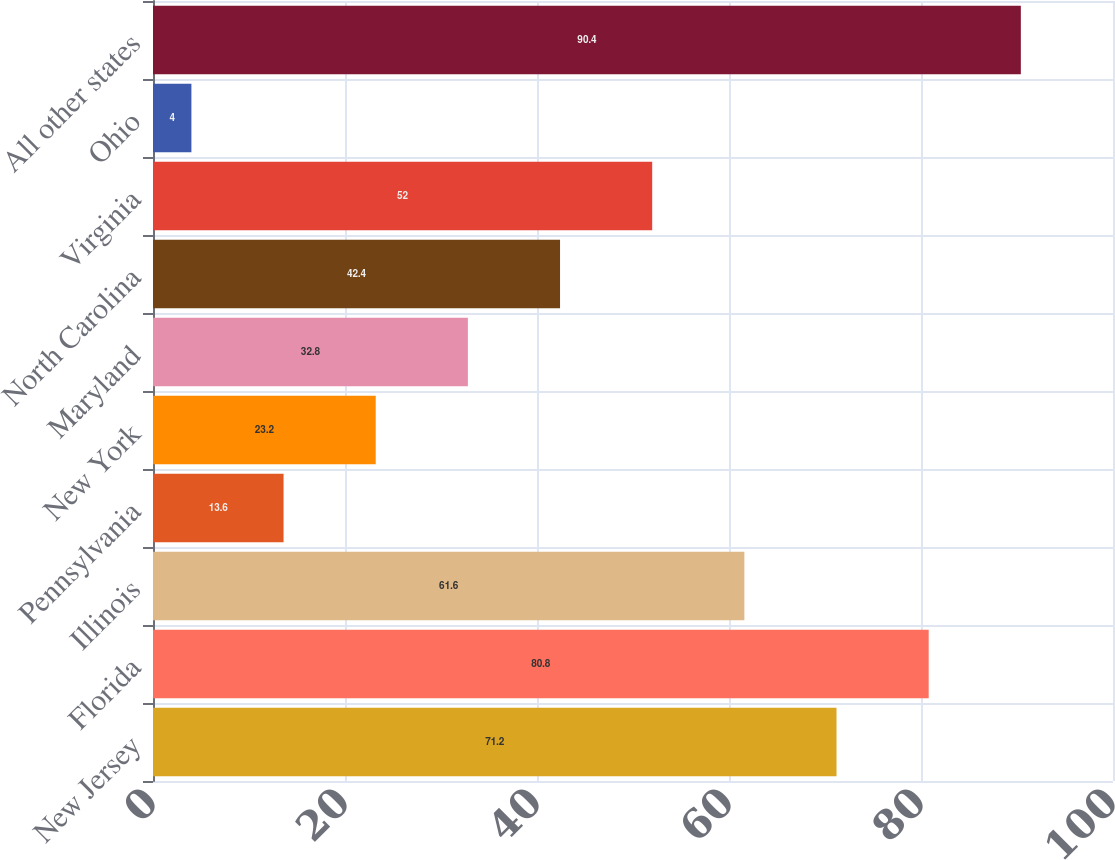Convert chart to OTSL. <chart><loc_0><loc_0><loc_500><loc_500><bar_chart><fcel>New Jersey<fcel>Florida<fcel>Illinois<fcel>Pennsylvania<fcel>New York<fcel>Maryland<fcel>North Carolina<fcel>Virginia<fcel>Ohio<fcel>All other states<nl><fcel>71.2<fcel>80.8<fcel>61.6<fcel>13.6<fcel>23.2<fcel>32.8<fcel>42.4<fcel>52<fcel>4<fcel>90.4<nl></chart> 